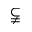<formula> <loc_0><loc_0><loc_500><loc_500>\subsetneqq</formula> 